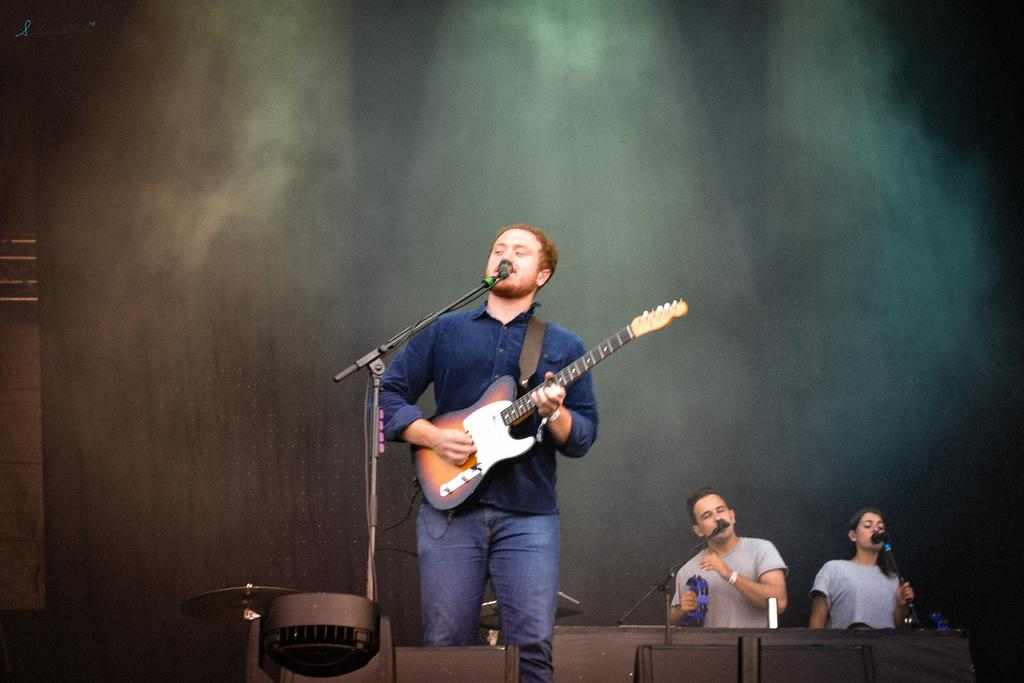What is the man in the image doing? The man is playing a guitar and singing into a microphone. Can you describe the man's activity in more detail? The man is performing, as he is playing a guitar and singing into a microphone. Are there any other people in the image? Yes, there is a man and a woman in the background of the image. What page is the man turning in the image? There is no reference to a book or page in the image, so it is not possible to determine what page might be turned. 